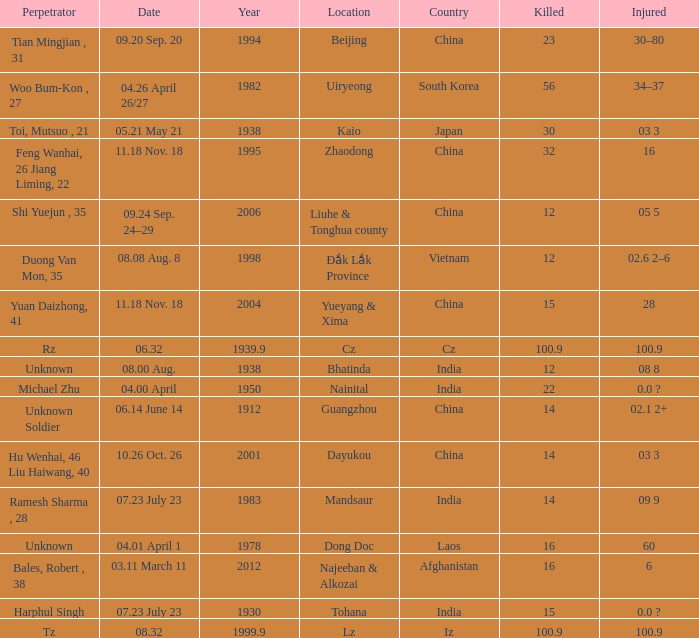Could you help me parse every detail presented in this table? {'header': ['Perpetrator', 'Date', 'Year', 'Location', 'Country', 'Killed', 'Injured'], 'rows': [['Tian Mingjian , 31', '09.20 Sep. 20', '1994', 'Beijing', 'China', '23', '30–80'], ['Woo Bum-Kon , 27', '04.26 April 26/27', '1982', 'Uiryeong', 'South Korea', '56', '34–37'], ['Toi, Mutsuo , 21', '05.21 May 21', '1938', 'Kaio', 'Japan', '30', '03 3'], ['Feng Wanhai, 26 Jiang Liming, 22', '11.18 Nov. 18', '1995', 'Zhaodong', 'China', '32', '16'], ['Shi Yuejun , 35', '09.24 Sep. 24–29', '2006', 'Liuhe & Tonghua county', 'China', '12', '05 5'], ['Duong Van Mon, 35', '08.08 Aug. 8', '1998', 'Đắk Lắk Province', 'Vietnam', '12', '02.6 2–6'], ['Yuan Daizhong, 41', '11.18 Nov. 18', '2004', 'Yueyang & Xima', 'China', '15', '28'], ['Rz', '06.32', '1939.9', 'Cz', 'Cz', '100.9', '100.9'], ['Unknown', '08.00 Aug.', '1938', 'Bhatinda', 'India', '12', '08 8'], ['Michael Zhu', '04.00 April', '1950', 'Nainital', 'India', '22', '0.0 ?'], ['Unknown Soldier', '06.14 June 14', '1912', 'Guangzhou', 'China', '14', '02.1 2+'], ['Hu Wenhai, 46 Liu Haiwang, 40', '10.26 Oct. 26', '2001', 'Dayukou', 'China', '14', '03 3'], ['Ramesh Sharma , 28', '07.23 July 23', '1983', 'Mandsaur', 'India', '14', '09 9'], ['Unknown', '04.01 April 1', '1978', 'Dong Doc', 'Laos', '16', '60'], ['Bales, Robert , 38', '03.11 March 11', '2012', 'Najeeban & Alkozai', 'Afghanistan', '16', '6'], ['Harphul Singh', '07.23 July 23', '1930', 'Tohana', 'India', '15', '0.0 ?'], ['Tz', '08.32', '1999.9', 'Lz', 'Iz', '100.9', '100.9']]} What is Date, when Country is "China", and when Perpetrator is "Shi Yuejun , 35"? 09.24 Sep. 24–29. 